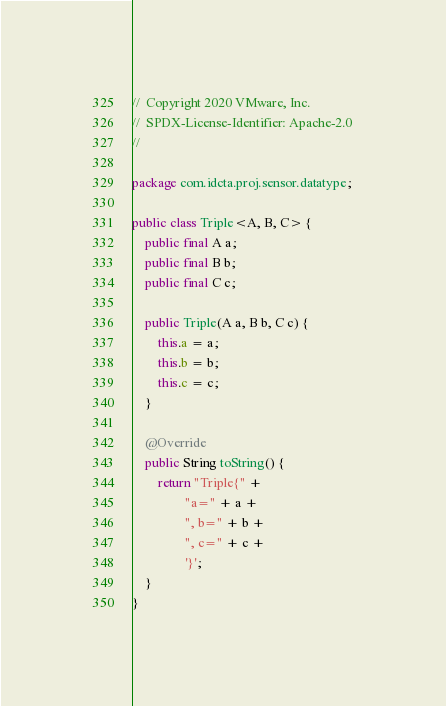<code> <loc_0><loc_0><loc_500><loc_500><_Java_>//  Copyright 2020 VMware, Inc.
//  SPDX-License-Identifier: Apache-2.0
//

package com.idcta.proj.sensor.datatype;

public class Triple<A, B, C> {
    public final A a;
    public final B b;
    public final C c;

    public Triple(A a, B b, C c) {
        this.a = a;
        this.b = b;
        this.c = c;
    }

    @Override
    public String toString() {
        return "Triple{" +
                "a=" + a +
                ", b=" + b +
                ", c=" + c +
                '}';
    }
}
</code> 